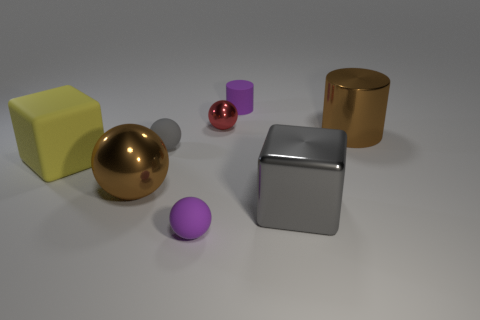Subtract all gray matte spheres. How many spheres are left? 3 Add 1 tiny green spheres. How many objects exist? 9 Subtract 2 cylinders. How many cylinders are left? 0 Subtract all gray blocks. How many blocks are left? 1 Subtract all cylinders. How many objects are left? 6 Add 8 purple things. How many purple things exist? 10 Subtract 0 purple cubes. How many objects are left? 8 Subtract all gray balls. Subtract all yellow cylinders. How many balls are left? 3 Subtract all small rubber cylinders. Subtract all brown balls. How many objects are left? 6 Add 5 metal cylinders. How many metal cylinders are left? 6 